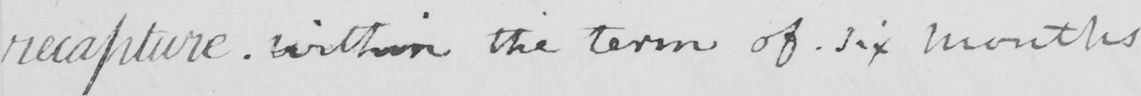What does this handwritten line say? recapture within the term of six months . 